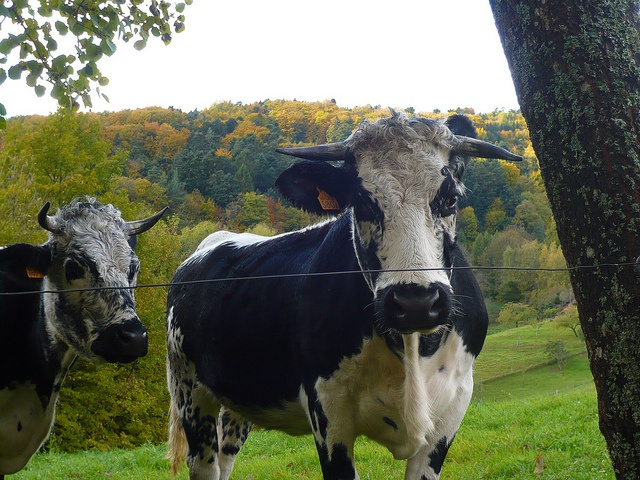Describe the objects in this image and their specific colors. I can see cow in olive, black, gray, darkgray, and darkgreen tones and cow in olive, black, gray, darkgray, and darkgreen tones in this image. 